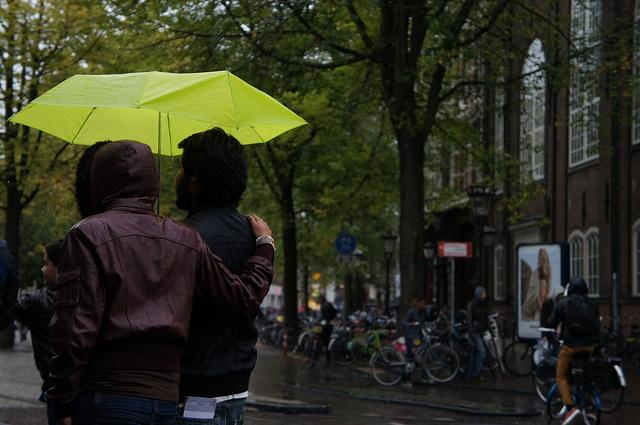Why are they using an umbrella?

Choices:
A) disguise
B) rain
C) sun
D) snow rain 